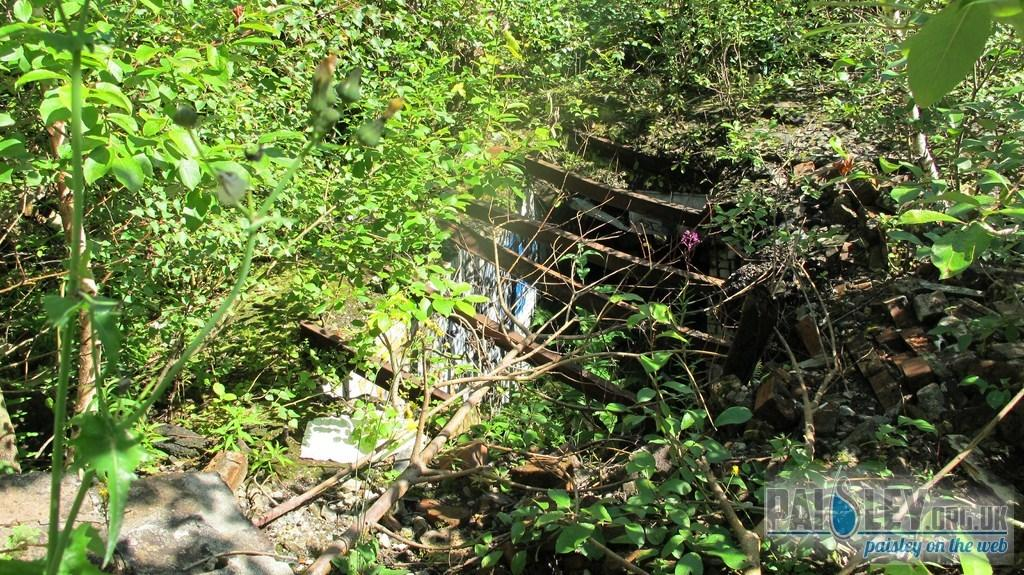What type of living organisms can be seen in the image? There is a group of plants in the image. What material is used for the planks in the middle of the group of plants? The planks are made of wood. What is the color and appearance of the substance under the wooden planks? There is a white color substance that resembles a wall under the wooden planks. How many frogs are sitting on the wooden planks in the image? There are no frogs present in the image; it features a group of plants, wooden planks, and a white color substance that resembles a wall. 